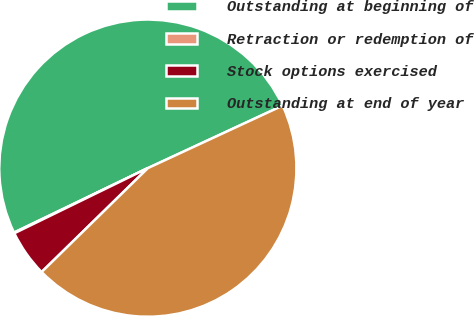Convert chart to OTSL. <chart><loc_0><loc_0><loc_500><loc_500><pie_chart><fcel>Outstanding at beginning of<fcel>Retraction or redemption of<fcel>Stock options exercised<fcel>Outstanding at end of year<nl><fcel>50.23%<fcel>0.08%<fcel>5.1%<fcel>44.59%<nl></chart> 